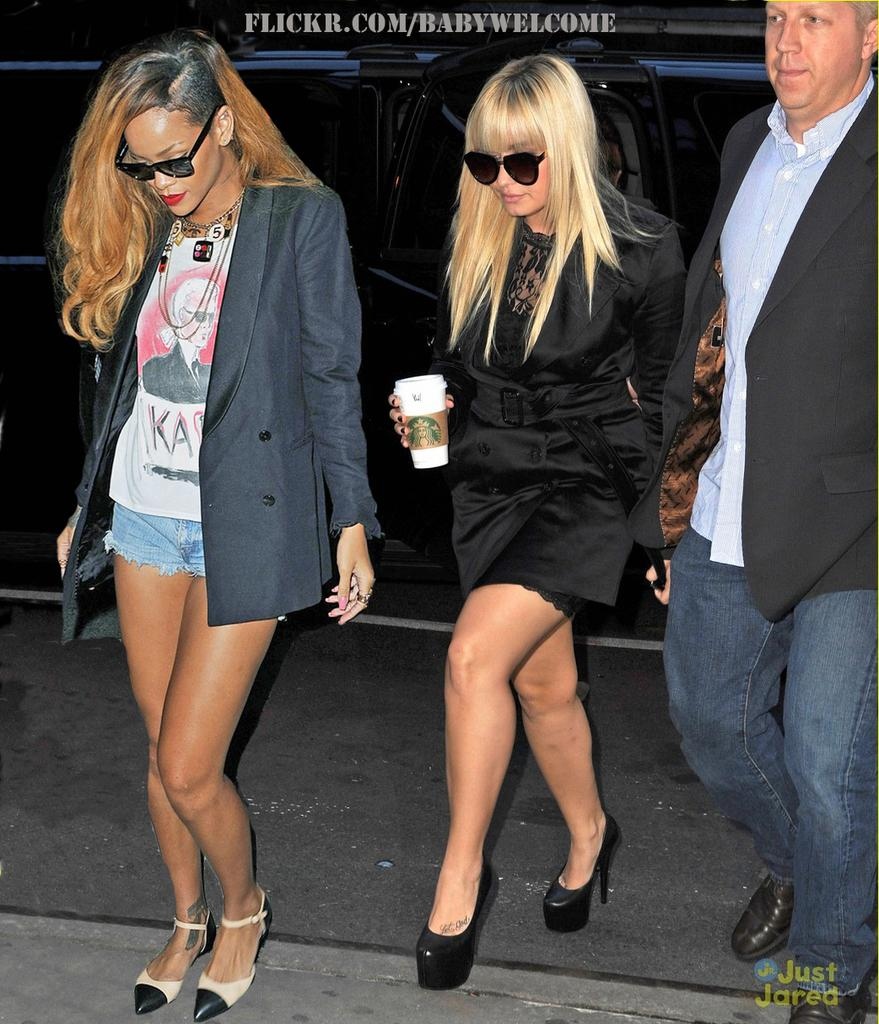How many people are in the picture? There are three people in the picture. Can you describe the gender of the people in the picture? Two of them are women, and one of them is a man. What are the people in the picture doing? The three people are walking. What type of clothing are the people wearing? They are wearing fashion attire. What is visible behind the three people? There is a vehicle behind the three people. What type of drum can be heard in the background of the image? There is no drum or any sound present in the image; it is a still picture. 